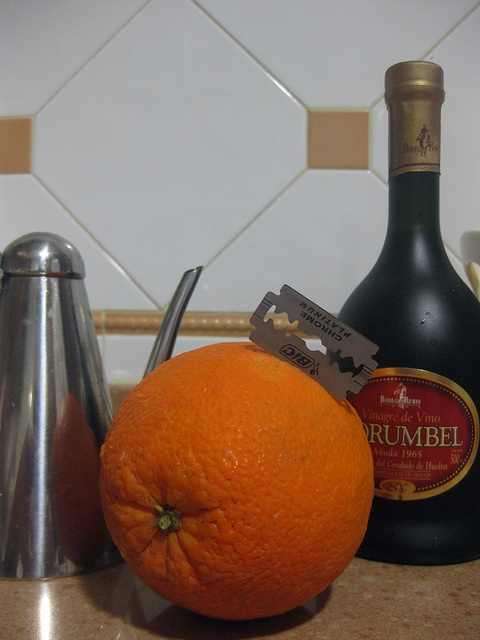Describe the objects in this image and their specific colors. I can see orange in gray, brown, maroon, and red tones and bottle in gray, black, maroon, and olive tones in this image. 